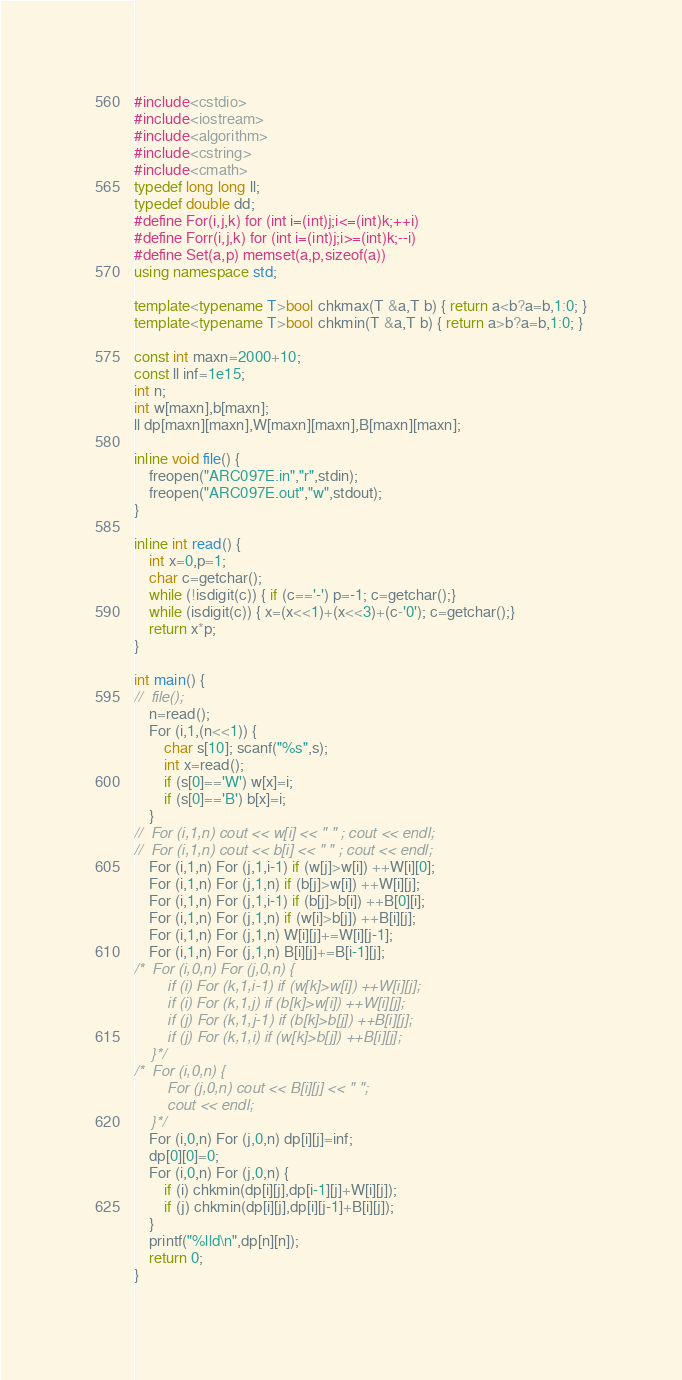Convert code to text. <code><loc_0><loc_0><loc_500><loc_500><_C++_>#include<cstdio>
#include<iostream>
#include<algorithm>
#include<cstring>
#include<cmath>
typedef long long ll;
typedef double dd;
#define For(i,j,k) for (int i=(int)j;i<=(int)k;++i)
#define Forr(i,j,k) for (int i=(int)j;i>=(int)k;--i)
#define Set(a,p) memset(a,p,sizeof(a))
using namespace std;

template<typename T>bool chkmax(T &a,T b) { return a<b?a=b,1:0; }
template<typename T>bool chkmin(T &a,T b) { return a>b?a=b,1:0; }

const int maxn=2000+10;
const ll inf=1e15;
int n;
int w[maxn],b[maxn];
ll dp[maxn][maxn],W[maxn][maxn],B[maxn][maxn];

inline void file() {
	freopen("ARC097E.in","r",stdin);
	freopen("ARC097E.out","w",stdout);
}

inline int read() {
	int x=0,p=1;
	char c=getchar();
	while (!isdigit(c)) { if (c=='-') p=-1; c=getchar();}
	while (isdigit(c)) { x=(x<<1)+(x<<3)+(c-'0'); c=getchar();}
	return x*p;
}

int main() {
//	file();
	n=read();
	For (i,1,(n<<1)) {
		char s[10]; scanf("%s",s);
		int x=read();
		if (s[0]=='W') w[x]=i;
		if (s[0]=='B') b[x]=i;
	}
//	For (i,1,n) cout << w[i] << " " ; cout << endl;
//	For (i,1,n) cout << b[i] << " " ; cout << endl;
	For (i,1,n) For (j,1,i-1) if (w[j]>w[i]) ++W[i][0];
	For (i,1,n) For (j,1,n) if (b[j]>w[i]) ++W[i][j];
	For (i,1,n) For (j,1,i-1) if (b[j]>b[i]) ++B[0][i];
	For (i,1,n) For (j,1,n) if (w[i]>b[j]) ++B[i][j];
	For (i,1,n) For (j,1,n) W[i][j]+=W[i][j-1];
	For (i,1,n) For (j,1,n) B[i][j]+=B[i-1][j];
/*	For (i,0,n) For (j,0,n) {
		if (i) For (k,1,i-1) if (w[k]>w[i]) ++W[i][j];
		if (i) For (k,1,j) if (b[k]>w[i]) ++W[i][j];
		if (j) For (k,1,j-1) if (b[k]>b[j]) ++B[i][j];
		if (j) For (k,1,i) if (w[k]>b[j]) ++B[i][j];
	}*/
/*	For (i,0,n) {
		For (j,0,n) cout << B[i][j] << " ";
		cout << endl;
	}*/
	For (i,0,n) For (j,0,n) dp[i][j]=inf;
	dp[0][0]=0;
	For (i,0,n) For (j,0,n) {
		if (i) chkmin(dp[i][j],dp[i-1][j]+W[i][j]);
		if (j) chkmin(dp[i][j],dp[i][j-1]+B[i][j]);
	}
	printf("%lld\n",dp[n][n]);
	return 0;
}</code> 